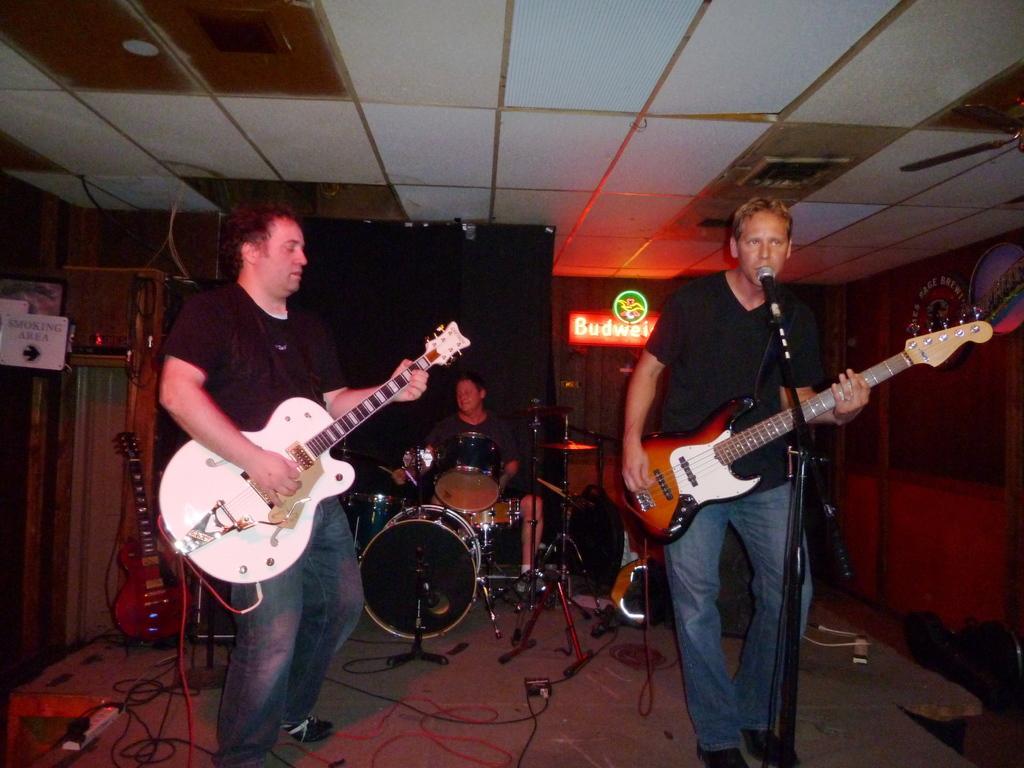Can you describe this image briefly? Here we can see couple of guys playing guitars and the guy on the right side is singing a song with a microphone present in front of him, the guy in the middle is playing drums 